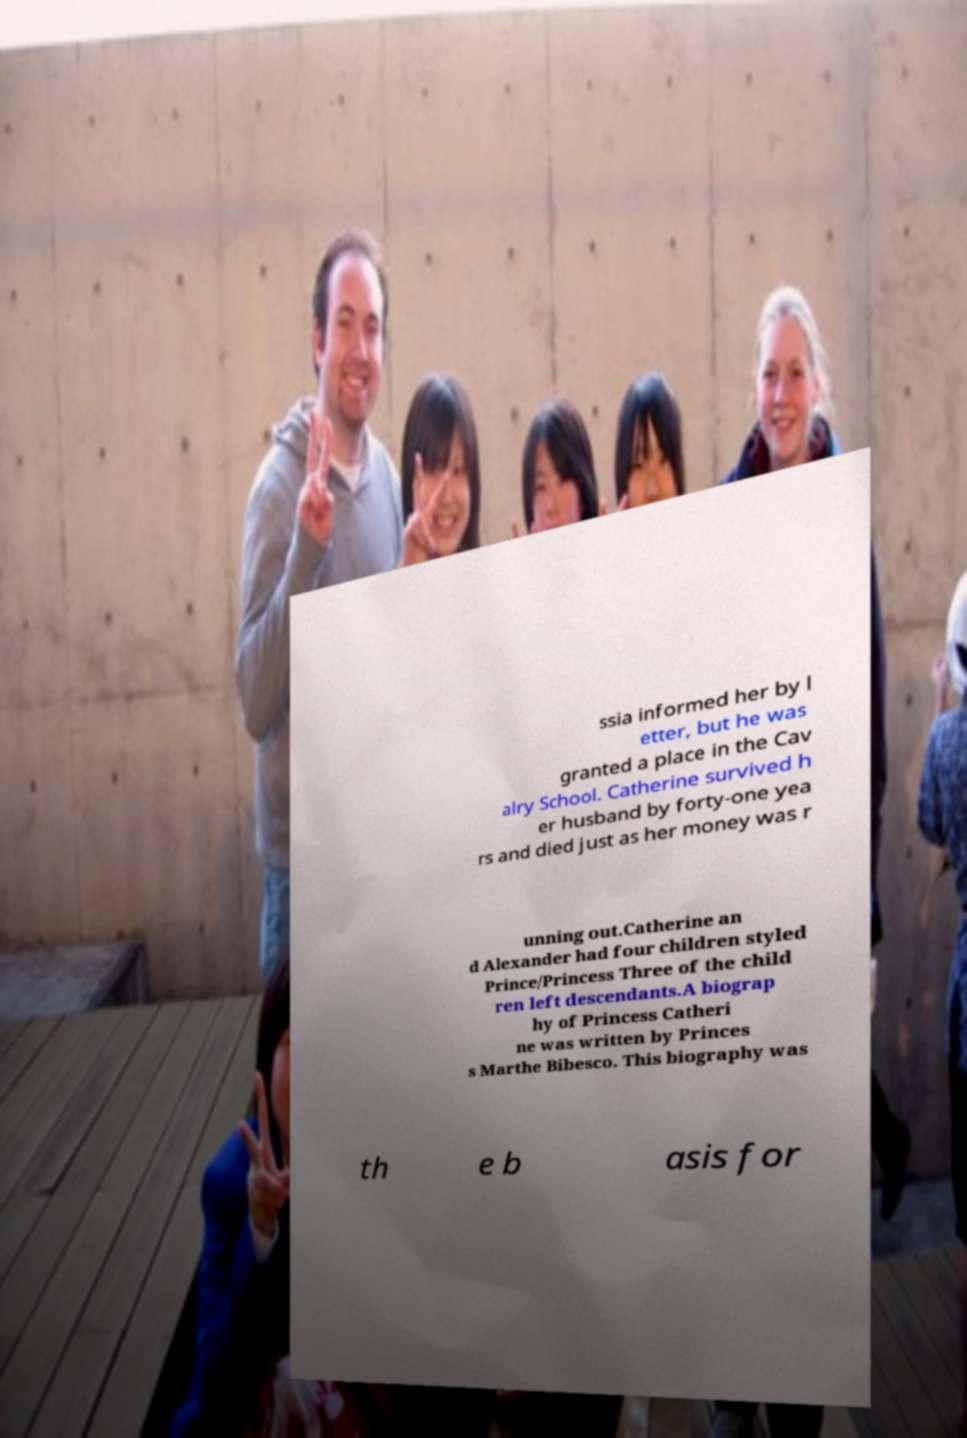What messages or text are displayed in this image? I need them in a readable, typed format. ssia informed her by l etter, but he was granted a place in the Cav alry School. Catherine survived h er husband by forty-one yea rs and died just as her money was r unning out.Catherine an d Alexander had four children styled Prince/Princess Three of the child ren left descendants.A biograp hy of Princess Catheri ne was written by Princes s Marthe Bibesco. This biography was th e b asis for 